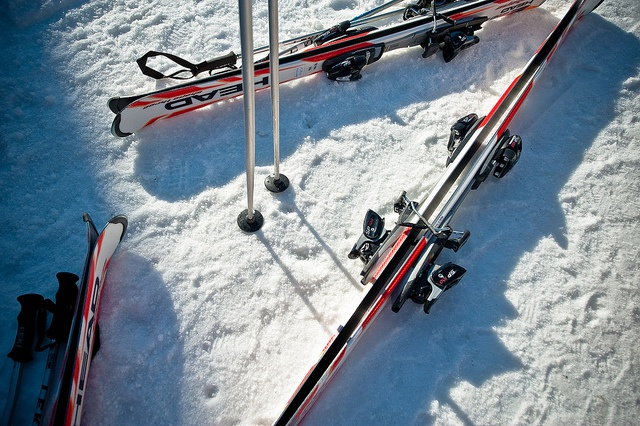Describe the objects in this image and their specific colors. I can see skis in navy, black, gray, white, and darkgray tones, skis in navy, black, darkgray, gray, and lightgray tones, and skis in navy, black, darkgray, and gray tones in this image. 